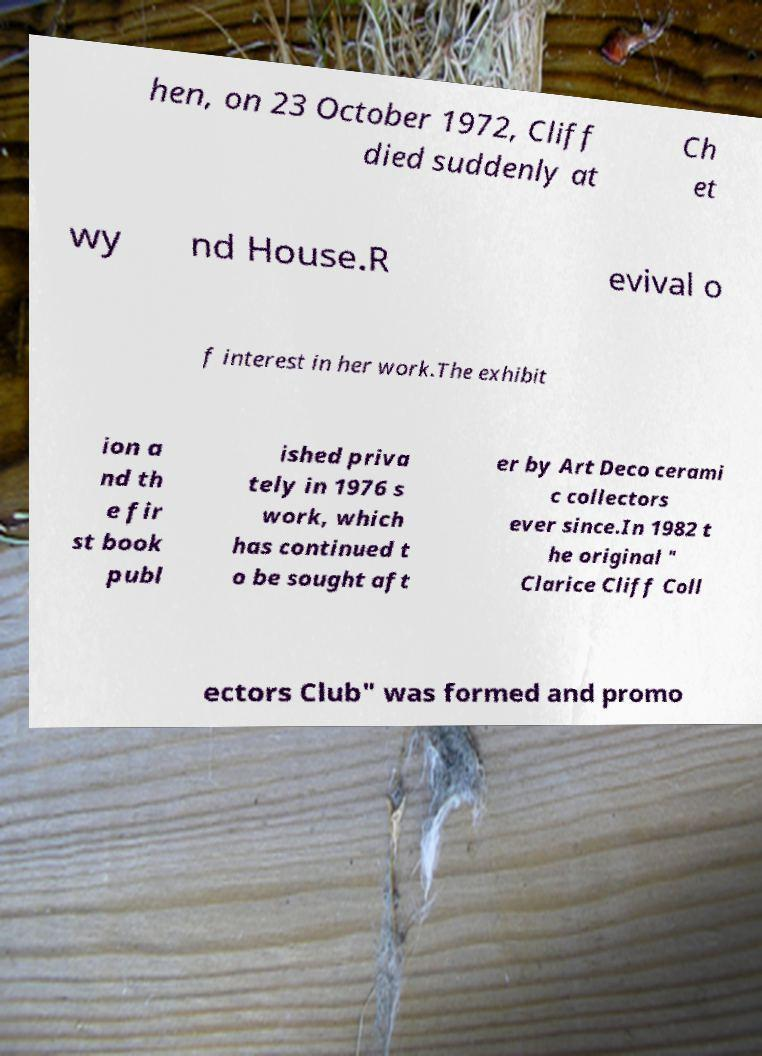There's text embedded in this image that I need extracted. Can you transcribe it verbatim? hen, on 23 October 1972, Cliff died suddenly at Ch et wy nd House.R evival o f interest in her work.The exhibit ion a nd th e fir st book publ ished priva tely in 1976 s work, which has continued t o be sought aft er by Art Deco cerami c collectors ever since.In 1982 t he original " Clarice Cliff Coll ectors Club" was formed and promo 